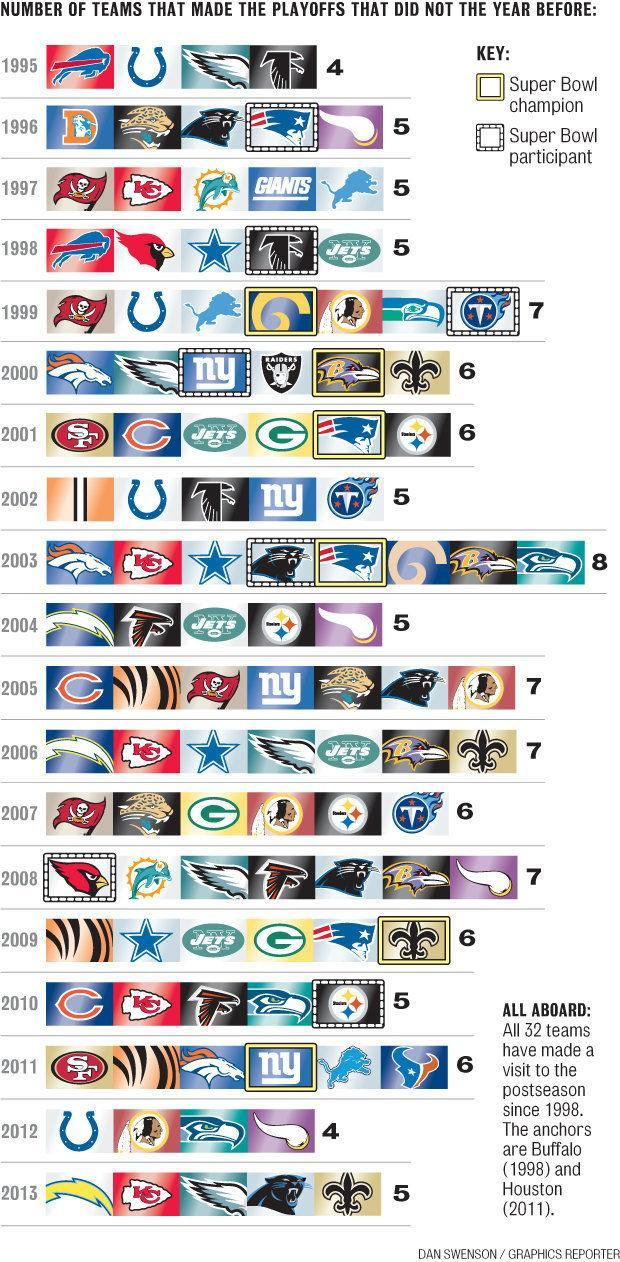What is the total number of NFL teams?
Answer the question with a short phrase. 32 teams How many NFL teams made the playoffs in 2011 that didn't the year before? 6 How many NFL teams made the playoffs in 1997 that didn't the year before? 5 